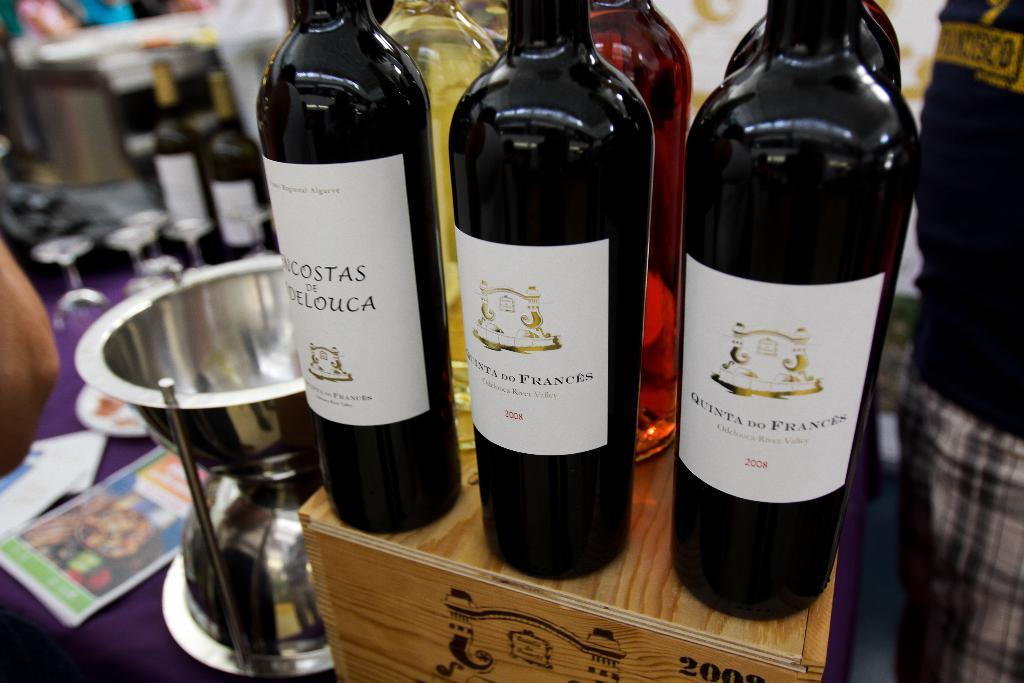<image>
Render a clear and concise summary of the photo. Three bottles of wine from 2008 are lined up on top of a wooden box. 